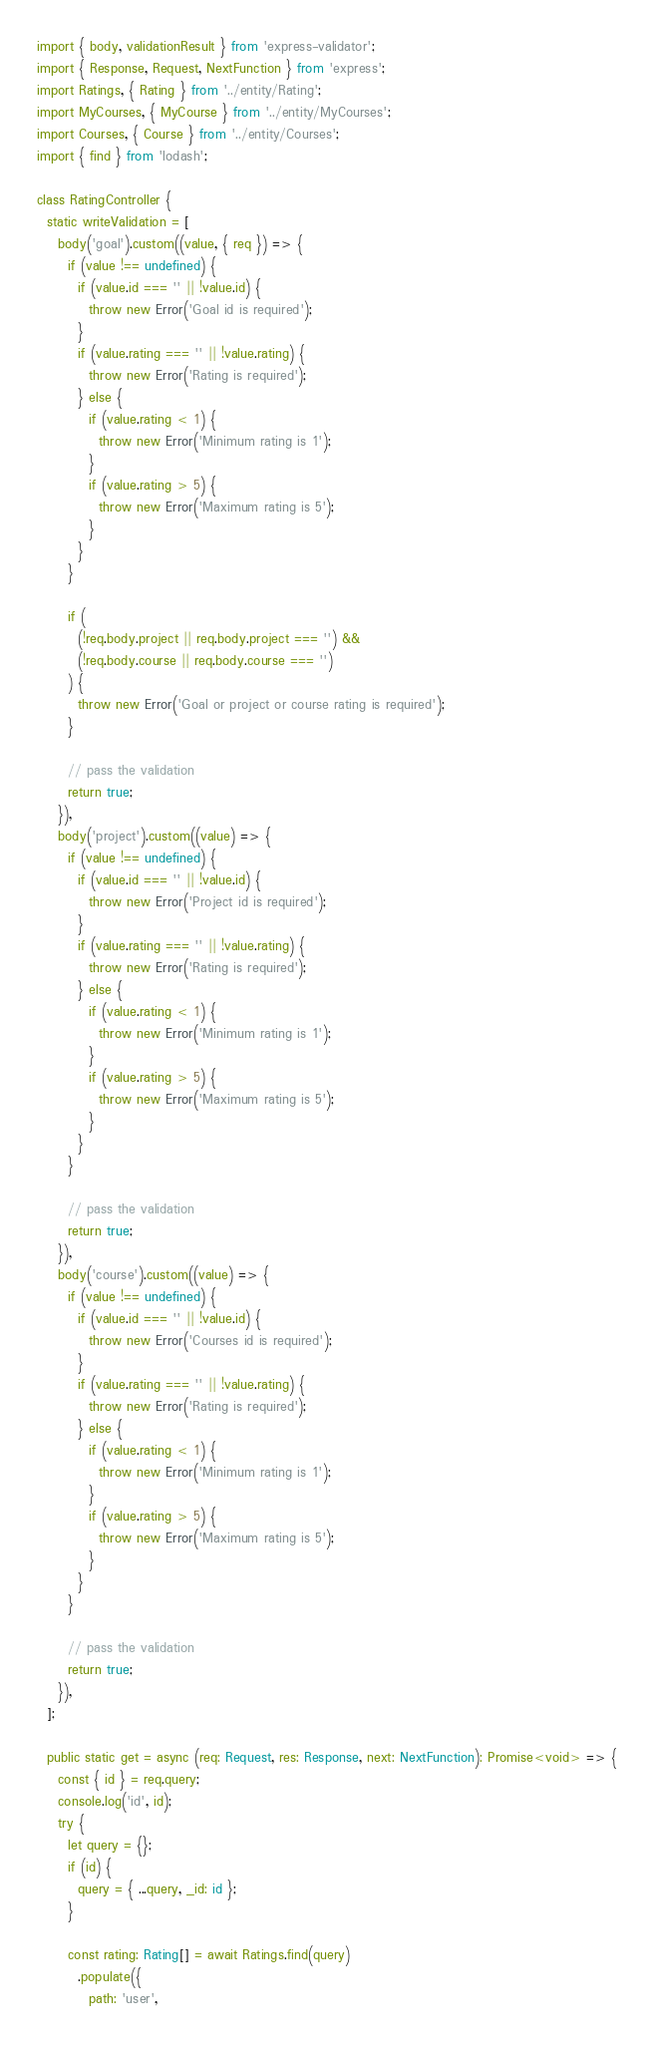Convert code to text. <code><loc_0><loc_0><loc_500><loc_500><_TypeScript_>import { body, validationResult } from 'express-validator';
import { Response, Request, NextFunction } from 'express';
import Ratings, { Rating } from '../entity/Rating';
import MyCourses, { MyCourse } from '../entity/MyCourses';
import Courses, { Course } from '../entity/Courses';
import { find } from 'lodash';

class RatingController {
  static writeValidation = [
    body('goal').custom((value, { req }) => {
      if (value !== undefined) {
        if (value.id === '' || !value.id) {
          throw new Error('Goal id is required');
        }
        if (value.rating === '' || !value.rating) {
          throw new Error('Rating is required');
        } else {
          if (value.rating < 1) {
            throw new Error('Minimum rating is 1');
          }
          if (value.rating > 5) {
            throw new Error('Maximum rating is 5');
          }
        }
      }

      if (
        (!req.body.project || req.body.project === '') &&
        (!req.body.course || req.body.course === '')
      ) {
        throw new Error('Goal or project or course rating is required');
      }

      // pass the validation
      return true;
    }),
    body('project').custom((value) => {
      if (value !== undefined) {
        if (value.id === '' || !value.id) {
          throw new Error('Project id is required');
        }
        if (value.rating === '' || !value.rating) {
          throw new Error('Rating is required');
        } else {
          if (value.rating < 1) {
            throw new Error('Minimum rating is 1');
          }
          if (value.rating > 5) {
            throw new Error('Maximum rating is 5');
          }
        }
      }

      // pass the validation
      return true;
    }),
    body('course').custom((value) => {
      if (value !== undefined) {
        if (value.id === '' || !value.id) {
          throw new Error('Courses id is required');
        }
        if (value.rating === '' || !value.rating) {
          throw new Error('Rating is required');
        } else {
          if (value.rating < 1) {
            throw new Error('Minimum rating is 1');
          }
          if (value.rating > 5) {
            throw new Error('Maximum rating is 5');
          }
        }
      }

      // pass the validation
      return true;
    }),
  ];

  public static get = async (req: Request, res: Response, next: NextFunction): Promise<void> => {
    const { id } = req.query;
    console.log('id', id);
    try {
      let query = {};
      if (id) {
        query = { ...query, _id: id };
      }

      const rating: Rating[] = await Ratings.find(query)
        .populate({
          path: 'user',</code> 